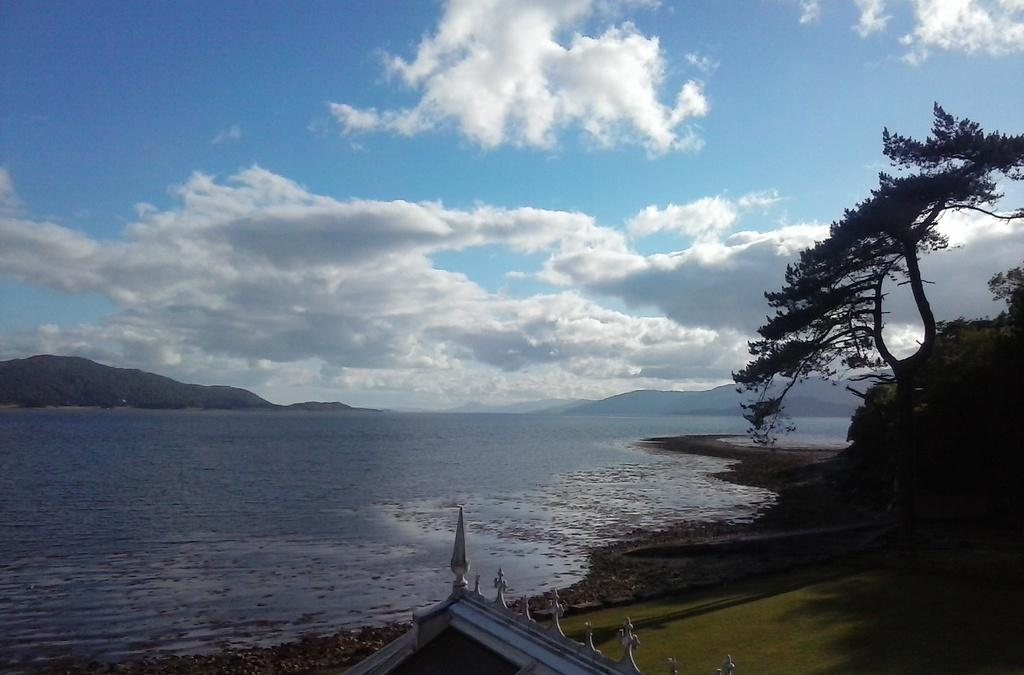What is the primary element present in the image? There is water in the image. What type of natural environment is depicted in the image? The image features trees and hills, indicating a natural setting. What can be seen in the background of the image? The sky is visible in the background of the image. What type of object is located at the bottom of the image? There is a metal object at the bottom of the image. How many clouds are visible in the image? There is no mention of clouds in the image; only the sky is visible in the background. What type of step is present in the image? There is no step present in the image. 